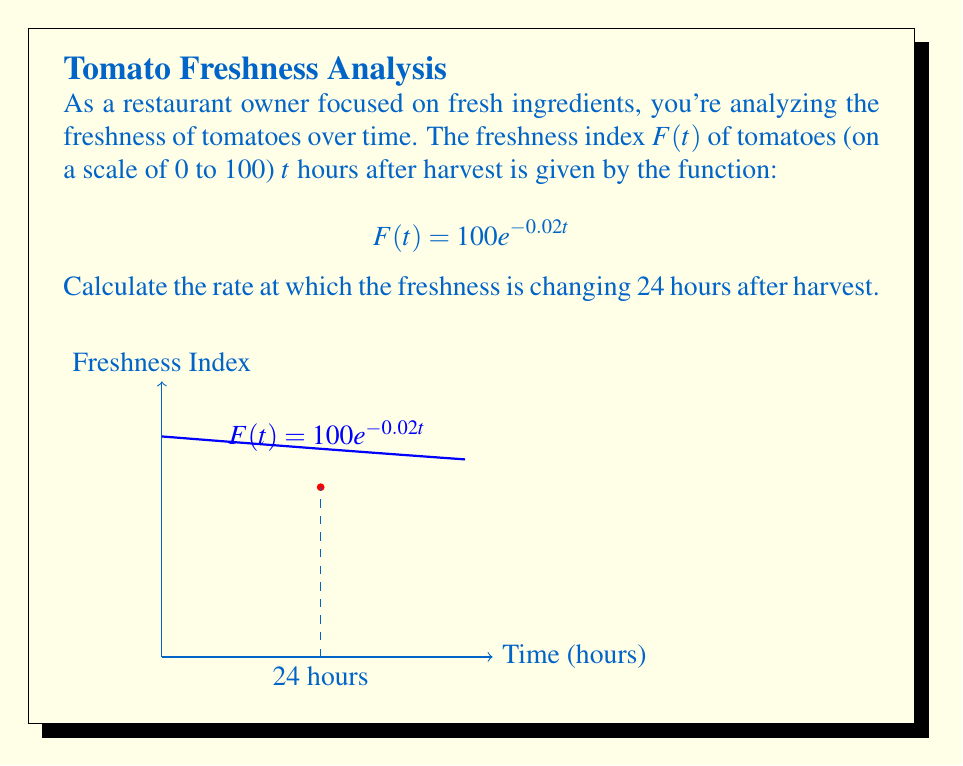What is the answer to this math problem? To find the rate of change in freshness at t = 24 hours, we need to calculate the derivative of $F(t)$ and evaluate it at t = 24.

Step 1: Calculate the derivative of $F(t)$
$$F(t) = 100e^{-0.02t}$$
$$F'(t) = 100 \cdot (-0.02) \cdot e^{-0.02t}$$
$$F'(t) = -2e^{-0.02t}$$

Step 2: Evaluate $F'(t)$ at t = 24
$$F'(24) = -2e^{-0.02(24)}$$
$$F'(24) = -2e^{-0.48}$$
$$F'(24) = -2 \cdot 0.6188...$$
$$F'(24) = -1.2376...$$

The negative value indicates that the freshness is decreasing. We can round this to two decimal places for practical use.
Answer: $-1.24$ units per hour 